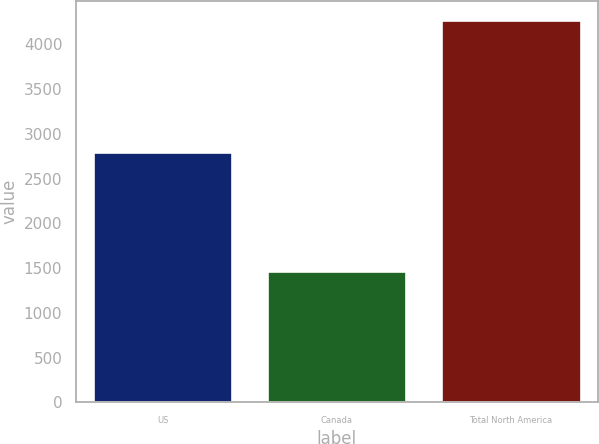<chart> <loc_0><loc_0><loc_500><loc_500><bar_chart><fcel>US<fcel>Canada<fcel>Total North America<nl><fcel>2801<fcel>1472<fcel>4273<nl></chart> 